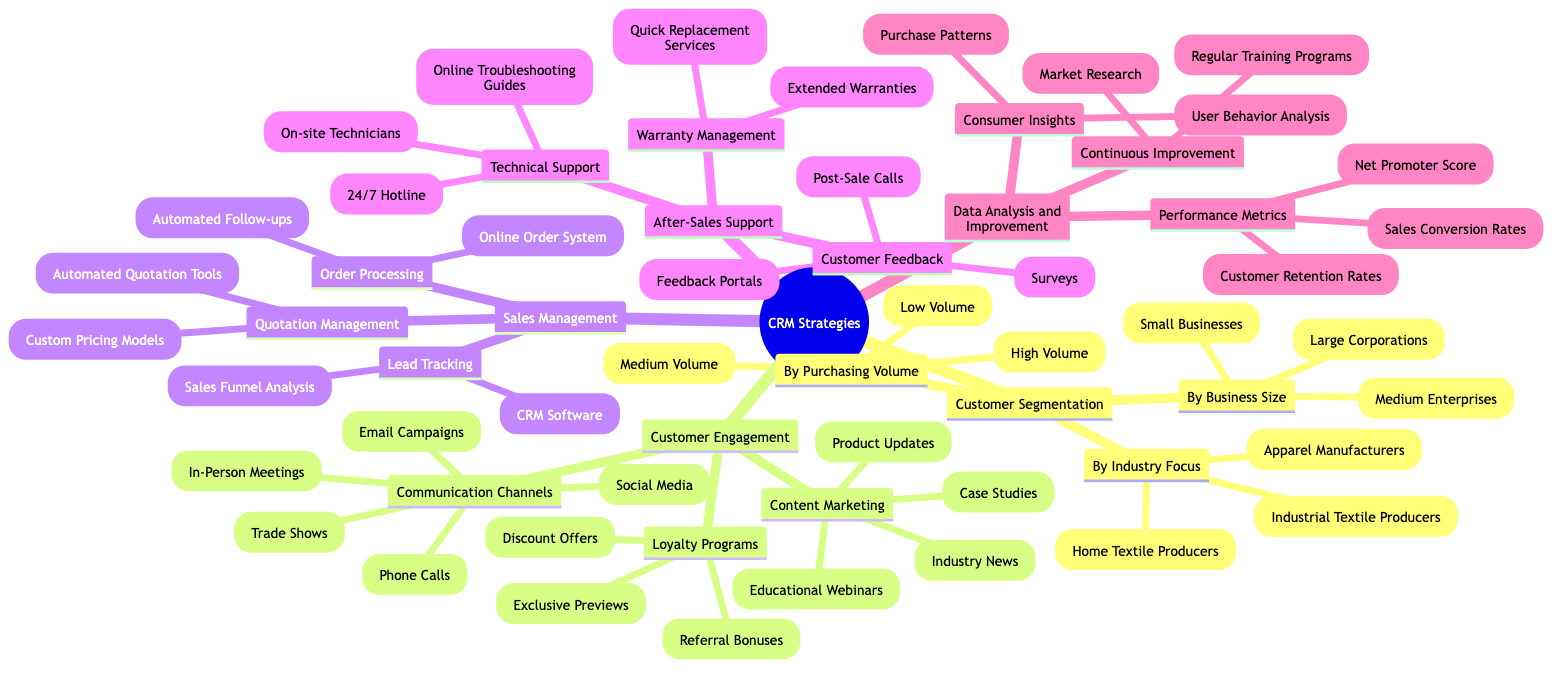What are the three categories of customer segmentation? The diagram lists under "Customer Segmentation" the three categories: "By Business Size", "By Purchasing Volume", and "By Industry Focus".
Answer: By Business Size, By Purchasing Volume, By Industry Focus How many communication channels are listed under customer engagement? The "Customer Engagement" section identifies five communication channels: "Email Campaigns", "Social Media", "Phone Calls", "In-Person Meetings", and "Trade Shows".
Answer: 5 What type of programs fall under customer engagement? The "Loyalty Programs" are mentioned under the "Customer Engagement" node, which includes "Discount Offers", "Exclusive Previews", and "Referral Bonuses".
Answer: Discount Offers, Exclusive Previews, Referral Bonuses What is the focus of the "Consumer Insights" in data analysis? The "Consumer Insights" node indicates focuses on "Purchase Patterns" and "User Behavior Analysis", which help understand customer trends and preferences.
Answer: Purchase Patterns, User Behavior Analysis How many different ways are there to manage quotations? The "Quotation Management" section includes two approaches: "Automated Quotation Tools" and "Custom Pricing Models", which means there are two distinct ways to manage quotations.
Answer: 2 What aspect of sales management can be tracked using CRM software? Under "Sales Management", "Lead Tracking" is specified as a task that can utilize "CRM Software", which means CRM software aids in tracking leads.
Answer: Lead Tracking What kind of support is offered after sales according to the diagram? The "After-Sales Support" section outlines several support types, including "Technical Support", "Warranty Management", and "Customer Feedback", indicating various post-sale services provided.
Answer: Technical Support, Warranty Management, Customer Feedback What performance metrics are analyzed in data analysis? The section mentions three performance metrics: "Customer Retention Rates", "Net Promoter Score", and "Sales Conversion Rates", which are evaluated to measure success.
Answer: Customer Retention Rates, Net Promoter Score, Sales Conversion Rates What is the total number of customer segments detailed in the diagram? The "Customer Segmentation" category lists three distinct segmentation types (By Business Size, By Purchasing Volume, and By Industry Focus), and each of those has multiple categories, totaling to nine segments overall.
Answer: 9 